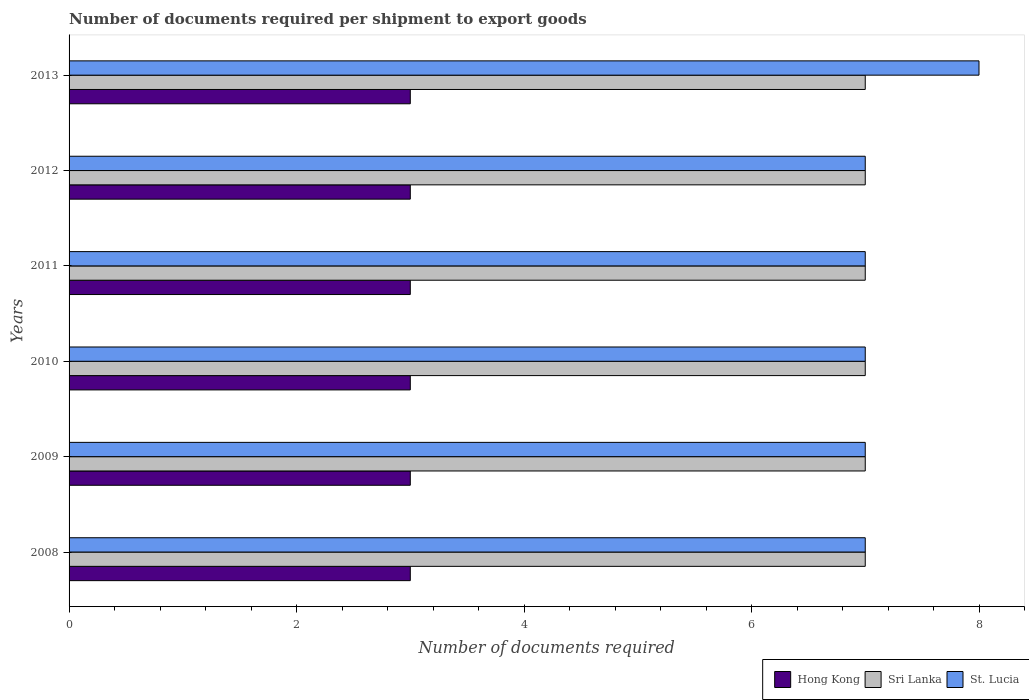How many groups of bars are there?
Your answer should be compact. 6. Are the number of bars per tick equal to the number of legend labels?
Ensure brevity in your answer.  Yes. Are the number of bars on each tick of the Y-axis equal?
Make the answer very short. Yes. What is the label of the 4th group of bars from the top?
Provide a short and direct response. 2010. What is the number of documents required per shipment to export goods in Sri Lanka in 2013?
Provide a succinct answer. 7. Across all years, what is the maximum number of documents required per shipment to export goods in Sri Lanka?
Make the answer very short. 7. Across all years, what is the minimum number of documents required per shipment to export goods in St. Lucia?
Your answer should be very brief. 7. In which year was the number of documents required per shipment to export goods in St. Lucia maximum?
Give a very brief answer. 2013. What is the total number of documents required per shipment to export goods in St. Lucia in the graph?
Your response must be concise. 43. What is the difference between the number of documents required per shipment to export goods in Hong Kong in 2010 and the number of documents required per shipment to export goods in St. Lucia in 2009?
Offer a very short reply. -4. What is the average number of documents required per shipment to export goods in Hong Kong per year?
Provide a succinct answer. 3. In the year 2008, what is the difference between the number of documents required per shipment to export goods in Hong Kong and number of documents required per shipment to export goods in St. Lucia?
Offer a very short reply. -4. In how many years, is the number of documents required per shipment to export goods in Sri Lanka greater than the average number of documents required per shipment to export goods in Sri Lanka taken over all years?
Keep it short and to the point. 0. Is the sum of the number of documents required per shipment to export goods in St. Lucia in 2009 and 2013 greater than the maximum number of documents required per shipment to export goods in Sri Lanka across all years?
Provide a succinct answer. Yes. What does the 2nd bar from the top in 2008 represents?
Give a very brief answer. Sri Lanka. What does the 1st bar from the bottom in 2013 represents?
Offer a very short reply. Hong Kong. Is it the case that in every year, the sum of the number of documents required per shipment to export goods in Hong Kong and number of documents required per shipment to export goods in Sri Lanka is greater than the number of documents required per shipment to export goods in St. Lucia?
Offer a very short reply. Yes. How many bars are there?
Keep it short and to the point. 18. Are the values on the major ticks of X-axis written in scientific E-notation?
Offer a terse response. No. Does the graph contain any zero values?
Ensure brevity in your answer.  No. What is the title of the graph?
Give a very brief answer. Number of documents required per shipment to export goods. Does "Congo (Democratic)" appear as one of the legend labels in the graph?
Your answer should be compact. No. What is the label or title of the X-axis?
Give a very brief answer. Number of documents required. What is the Number of documents required of Hong Kong in 2008?
Offer a very short reply. 3. What is the Number of documents required of St. Lucia in 2008?
Ensure brevity in your answer.  7. What is the Number of documents required of Hong Kong in 2009?
Ensure brevity in your answer.  3. What is the Number of documents required in Sri Lanka in 2009?
Keep it short and to the point. 7. What is the Number of documents required in St. Lucia in 2009?
Give a very brief answer. 7. What is the Number of documents required of Hong Kong in 2010?
Provide a short and direct response. 3. What is the Number of documents required of Sri Lanka in 2010?
Give a very brief answer. 7. What is the Number of documents required in Sri Lanka in 2011?
Give a very brief answer. 7. What is the Number of documents required of St. Lucia in 2011?
Give a very brief answer. 7. What is the Number of documents required in St. Lucia in 2012?
Offer a terse response. 7. What is the Number of documents required in Hong Kong in 2013?
Offer a terse response. 3. What is the Number of documents required of St. Lucia in 2013?
Offer a very short reply. 8. Across all years, what is the maximum Number of documents required in Hong Kong?
Provide a short and direct response. 3. Across all years, what is the minimum Number of documents required of Hong Kong?
Your answer should be compact. 3. Across all years, what is the minimum Number of documents required of St. Lucia?
Ensure brevity in your answer.  7. What is the total Number of documents required in Sri Lanka in the graph?
Give a very brief answer. 42. What is the difference between the Number of documents required of Sri Lanka in 2008 and that in 2009?
Offer a terse response. 0. What is the difference between the Number of documents required of St. Lucia in 2008 and that in 2009?
Your answer should be very brief. 0. What is the difference between the Number of documents required of Hong Kong in 2008 and that in 2010?
Make the answer very short. 0. What is the difference between the Number of documents required of Sri Lanka in 2008 and that in 2010?
Your answer should be compact. 0. What is the difference between the Number of documents required in St. Lucia in 2008 and that in 2010?
Your answer should be very brief. 0. What is the difference between the Number of documents required of Sri Lanka in 2008 and that in 2011?
Provide a short and direct response. 0. What is the difference between the Number of documents required of St. Lucia in 2008 and that in 2011?
Keep it short and to the point. 0. What is the difference between the Number of documents required in Hong Kong in 2008 and that in 2012?
Make the answer very short. 0. What is the difference between the Number of documents required in Hong Kong in 2008 and that in 2013?
Offer a terse response. 0. What is the difference between the Number of documents required of Sri Lanka in 2008 and that in 2013?
Provide a short and direct response. 0. What is the difference between the Number of documents required in Sri Lanka in 2009 and that in 2010?
Your answer should be compact. 0. What is the difference between the Number of documents required of St. Lucia in 2009 and that in 2010?
Provide a succinct answer. 0. What is the difference between the Number of documents required of Hong Kong in 2009 and that in 2011?
Keep it short and to the point. 0. What is the difference between the Number of documents required of St. Lucia in 2009 and that in 2011?
Give a very brief answer. 0. What is the difference between the Number of documents required in Hong Kong in 2009 and that in 2012?
Provide a short and direct response. 0. What is the difference between the Number of documents required in Sri Lanka in 2009 and that in 2012?
Keep it short and to the point. 0. What is the difference between the Number of documents required of St. Lucia in 2009 and that in 2012?
Ensure brevity in your answer.  0. What is the difference between the Number of documents required of Hong Kong in 2009 and that in 2013?
Give a very brief answer. 0. What is the difference between the Number of documents required of Sri Lanka in 2010 and that in 2011?
Provide a succinct answer. 0. What is the difference between the Number of documents required of Sri Lanka in 2011 and that in 2012?
Provide a succinct answer. 0. What is the difference between the Number of documents required in St. Lucia in 2011 and that in 2012?
Give a very brief answer. 0. What is the difference between the Number of documents required in Hong Kong in 2011 and that in 2013?
Offer a very short reply. 0. What is the difference between the Number of documents required of Sri Lanka in 2011 and that in 2013?
Your response must be concise. 0. What is the difference between the Number of documents required of St. Lucia in 2011 and that in 2013?
Provide a succinct answer. -1. What is the difference between the Number of documents required in Hong Kong in 2012 and that in 2013?
Make the answer very short. 0. What is the difference between the Number of documents required of Sri Lanka in 2012 and that in 2013?
Ensure brevity in your answer.  0. What is the difference between the Number of documents required in St. Lucia in 2012 and that in 2013?
Your answer should be compact. -1. What is the difference between the Number of documents required of Sri Lanka in 2008 and the Number of documents required of St. Lucia in 2009?
Your answer should be very brief. 0. What is the difference between the Number of documents required in Hong Kong in 2008 and the Number of documents required in Sri Lanka in 2010?
Your answer should be compact. -4. What is the difference between the Number of documents required of Sri Lanka in 2008 and the Number of documents required of St. Lucia in 2010?
Provide a succinct answer. 0. What is the difference between the Number of documents required in Hong Kong in 2008 and the Number of documents required in Sri Lanka in 2011?
Offer a very short reply. -4. What is the difference between the Number of documents required of Sri Lanka in 2008 and the Number of documents required of St. Lucia in 2011?
Make the answer very short. 0. What is the difference between the Number of documents required of Hong Kong in 2008 and the Number of documents required of Sri Lanka in 2012?
Keep it short and to the point. -4. What is the difference between the Number of documents required of Sri Lanka in 2008 and the Number of documents required of St. Lucia in 2012?
Make the answer very short. 0. What is the difference between the Number of documents required of Hong Kong in 2008 and the Number of documents required of Sri Lanka in 2013?
Your answer should be compact. -4. What is the difference between the Number of documents required in Hong Kong in 2008 and the Number of documents required in St. Lucia in 2013?
Provide a short and direct response. -5. What is the difference between the Number of documents required in Hong Kong in 2009 and the Number of documents required in St. Lucia in 2010?
Offer a very short reply. -4. What is the difference between the Number of documents required in Sri Lanka in 2009 and the Number of documents required in St. Lucia in 2010?
Your answer should be compact. 0. What is the difference between the Number of documents required in Sri Lanka in 2009 and the Number of documents required in St. Lucia in 2011?
Your response must be concise. 0. What is the difference between the Number of documents required of Hong Kong in 2009 and the Number of documents required of St. Lucia in 2012?
Give a very brief answer. -4. What is the difference between the Number of documents required in Hong Kong in 2009 and the Number of documents required in Sri Lanka in 2013?
Ensure brevity in your answer.  -4. What is the difference between the Number of documents required of Hong Kong in 2009 and the Number of documents required of St. Lucia in 2013?
Make the answer very short. -5. What is the difference between the Number of documents required of Hong Kong in 2010 and the Number of documents required of St. Lucia in 2011?
Provide a succinct answer. -4. What is the difference between the Number of documents required of Sri Lanka in 2010 and the Number of documents required of St. Lucia in 2011?
Offer a terse response. 0. What is the difference between the Number of documents required in Hong Kong in 2010 and the Number of documents required in Sri Lanka in 2012?
Offer a terse response. -4. What is the difference between the Number of documents required of Hong Kong in 2010 and the Number of documents required of St. Lucia in 2012?
Your answer should be very brief. -4. What is the difference between the Number of documents required of Sri Lanka in 2010 and the Number of documents required of St. Lucia in 2013?
Make the answer very short. -1. What is the difference between the Number of documents required in Hong Kong in 2011 and the Number of documents required in Sri Lanka in 2012?
Keep it short and to the point. -4. What is the difference between the Number of documents required of Hong Kong in 2011 and the Number of documents required of St. Lucia in 2012?
Ensure brevity in your answer.  -4. What is the difference between the Number of documents required of Sri Lanka in 2011 and the Number of documents required of St. Lucia in 2012?
Provide a succinct answer. 0. What is the difference between the Number of documents required of Hong Kong in 2011 and the Number of documents required of Sri Lanka in 2013?
Ensure brevity in your answer.  -4. What is the difference between the Number of documents required of Hong Kong in 2011 and the Number of documents required of St. Lucia in 2013?
Ensure brevity in your answer.  -5. What is the difference between the Number of documents required in Hong Kong in 2012 and the Number of documents required in St. Lucia in 2013?
Ensure brevity in your answer.  -5. What is the difference between the Number of documents required of Sri Lanka in 2012 and the Number of documents required of St. Lucia in 2013?
Ensure brevity in your answer.  -1. What is the average Number of documents required in St. Lucia per year?
Ensure brevity in your answer.  7.17. In the year 2008, what is the difference between the Number of documents required of Hong Kong and Number of documents required of Sri Lanka?
Offer a very short reply. -4. In the year 2008, what is the difference between the Number of documents required in Hong Kong and Number of documents required in St. Lucia?
Your answer should be compact. -4. In the year 2009, what is the difference between the Number of documents required in Hong Kong and Number of documents required in Sri Lanka?
Your response must be concise. -4. In the year 2010, what is the difference between the Number of documents required of Hong Kong and Number of documents required of St. Lucia?
Ensure brevity in your answer.  -4. In the year 2010, what is the difference between the Number of documents required in Sri Lanka and Number of documents required in St. Lucia?
Offer a very short reply. 0. In the year 2011, what is the difference between the Number of documents required of Hong Kong and Number of documents required of St. Lucia?
Make the answer very short. -4. In the year 2012, what is the difference between the Number of documents required in Hong Kong and Number of documents required in St. Lucia?
Your answer should be very brief. -4. In the year 2012, what is the difference between the Number of documents required of Sri Lanka and Number of documents required of St. Lucia?
Ensure brevity in your answer.  0. In the year 2013, what is the difference between the Number of documents required of Hong Kong and Number of documents required of Sri Lanka?
Give a very brief answer. -4. What is the ratio of the Number of documents required in Hong Kong in 2008 to that in 2009?
Offer a terse response. 1. What is the ratio of the Number of documents required of Sri Lanka in 2008 to that in 2009?
Your response must be concise. 1. What is the ratio of the Number of documents required of Sri Lanka in 2008 to that in 2010?
Your answer should be very brief. 1. What is the ratio of the Number of documents required of Sri Lanka in 2008 to that in 2011?
Your answer should be very brief. 1. What is the ratio of the Number of documents required of St. Lucia in 2008 to that in 2011?
Your response must be concise. 1. What is the ratio of the Number of documents required in Sri Lanka in 2008 to that in 2012?
Offer a very short reply. 1. What is the ratio of the Number of documents required of Sri Lanka in 2008 to that in 2013?
Provide a short and direct response. 1. What is the ratio of the Number of documents required in Hong Kong in 2009 to that in 2010?
Your answer should be compact. 1. What is the ratio of the Number of documents required of Sri Lanka in 2009 to that in 2010?
Keep it short and to the point. 1. What is the ratio of the Number of documents required in St. Lucia in 2009 to that in 2010?
Your answer should be compact. 1. What is the ratio of the Number of documents required of Hong Kong in 2009 to that in 2012?
Offer a very short reply. 1. What is the ratio of the Number of documents required of Sri Lanka in 2009 to that in 2012?
Provide a succinct answer. 1. What is the ratio of the Number of documents required of St. Lucia in 2009 to that in 2012?
Ensure brevity in your answer.  1. What is the ratio of the Number of documents required of St. Lucia in 2009 to that in 2013?
Offer a terse response. 0.88. What is the ratio of the Number of documents required of Hong Kong in 2010 to that in 2012?
Ensure brevity in your answer.  1. What is the ratio of the Number of documents required in Sri Lanka in 2010 to that in 2012?
Keep it short and to the point. 1. What is the ratio of the Number of documents required of St. Lucia in 2010 to that in 2012?
Keep it short and to the point. 1. What is the ratio of the Number of documents required of Sri Lanka in 2010 to that in 2013?
Provide a short and direct response. 1. What is the ratio of the Number of documents required of St. Lucia in 2011 to that in 2012?
Give a very brief answer. 1. What is the ratio of the Number of documents required in Hong Kong in 2011 to that in 2013?
Your answer should be compact. 1. What is the ratio of the Number of documents required of Sri Lanka in 2011 to that in 2013?
Your response must be concise. 1. What is the ratio of the Number of documents required of St. Lucia in 2011 to that in 2013?
Keep it short and to the point. 0.88. What is the ratio of the Number of documents required in Hong Kong in 2012 to that in 2013?
Keep it short and to the point. 1. What is the ratio of the Number of documents required of Sri Lanka in 2012 to that in 2013?
Your answer should be very brief. 1. What is the difference between the highest and the lowest Number of documents required of Hong Kong?
Provide a succinct answer. 0. What is the difference between the highest and the lowest Number of documents required of St. Lucia?
Ensure brevity in your answer.  1. 